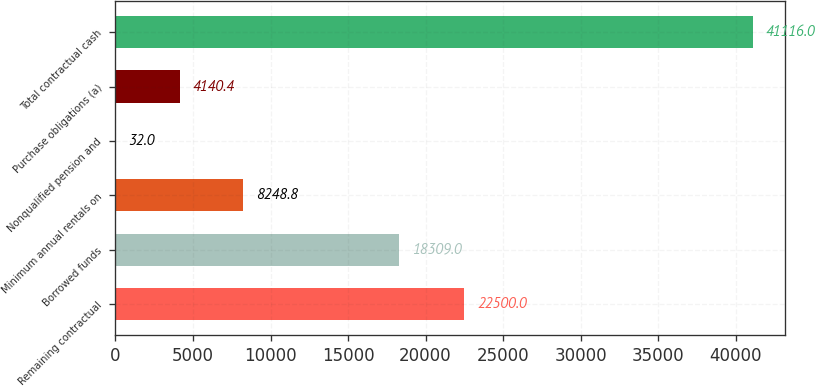Convert chart to OTSL. <chart><loc_0><loc_0><loc_500><loc_500><bar_chart><fcel>Remaining contractual<fcel>Borrowed funds<fcel>Minimum annual rentals on<fcel>Nonqualified pension and<fcel>Purchase obligations (a)<fcel>Total contractual cash<nl><fcel>22500<fcel>18309<fcel>8248.8<fcel>32<fcel>4140.4<fcel>41116<nl></chart> 